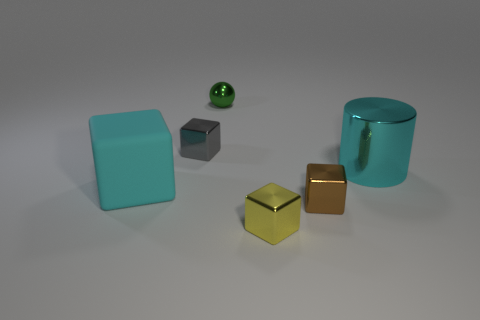Subtract all big blocks. How many blocks are left? 3 Subtract all cyan blocks. How many blocks are left? 3 Add 3 small green things. How many objects exist? 9 Subtract all blocks. How many objects are left? 2 Subtract all red cubes. Subtract all purple spheres. How many cubes are left? 4 Subtract all yellow metallic cylinders. Subtract all small metal cubes. How many objects are left? 3 Add 6 shiny cubes. How many shiny cubes are left? 9 Add 1 cyan cylinders. How many cyan cylinders exist? 2 Subtract 1 brown blocks. How many objects are left? 5 